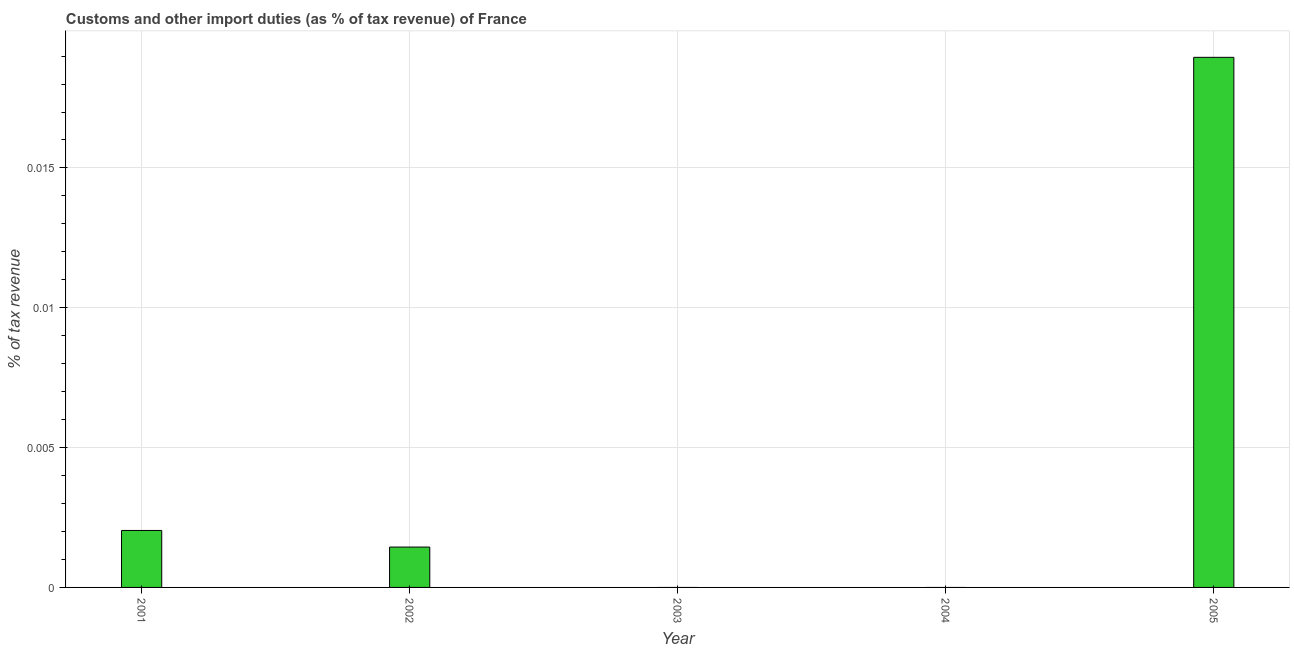What is the title of the graph?
Make the answer very short. Customs and other import duties (as % of tax revenue) of France. What is the label or title of the X-axis?
Make the answer very short. Year. What is the label or title of the Y-axis?
Ensure brevity in your answer.  % of tax revenue. What is the customs and other import duties in 2002?
Provide a succinct answer. 0. Across all years, what is the maximum customs and other import duties?
Keep it short and to the point. 0.02. In which year was the customs and other import duties maximum?
Your answer should be compact. 2005. What is the sum of the customs and other import duties?
Make the answer very short. 0.02. What is the difference between the customs and other import duties in 2002 and 2005?
Keep it short and to the point. -0.02. What is the average customs and other import duties per year?
Your answer should be very brief. 0. What is the median customs and other import duties?
Your answer should be compact. 0. What is the ratio of the customs and other import duties in 2001 to that in 2005?
Offer a terse response. 0.11. Is the customs and other import duties in 2001 less than that in 2002?
Offer a very short reply. No. Is the difference between the customs and other import duties in 2001 and 2005 greater than the difference between any two years?
Make the answer very short. No. What is the difference between the highest and the second highest customs and other import duties?
Your answer should be very brief. 0.02. What is the difference between the highest and the lowest customs and other import duties?
Offer a very short reply. 0.02. In how many years, is the customs and other import duties greater than the average customs and other import duties taken over all years?
Offer a terse response. 1. Are all the bars in the graph horizontal?
Your answer should be very brief. No. How many years are there in the graph?
Keep it short and to the point. 5. What is the difference between two consecutive major ticks on the Y-axis?
Your answer should be very brief. 0.01. What is the % of tax revenue of 2001?
Offer a terse response. 0. What is the % of tax revenue of 2002?
Offer a terse response. 0. What is the % of tax revenue of 2005?
Your answer should be compact. 0.02. What is the difference between the % of tax revenue in 2001 and 2002?
Your response must be concise. 0. What is the difference between the % of tax revenue in 2001 and 2005?
Ensure brevity in your answer.  -0.02. What is the difference between the % of tax revenue in 2002 and 2005?
Your answer should be very brief. -0.02. What is the ratio of the % of tax revenue in 2001 to that in 2002?
Offer a terse response. 1.41. What is the ratio of the % of tax revenue in 2001 to that in 2005?
Offer a terse response. 0.11. What is the ratio of the % of tax revenue in 2002 to that in 2005?
Ensure brevity in your answer.  0.08. 